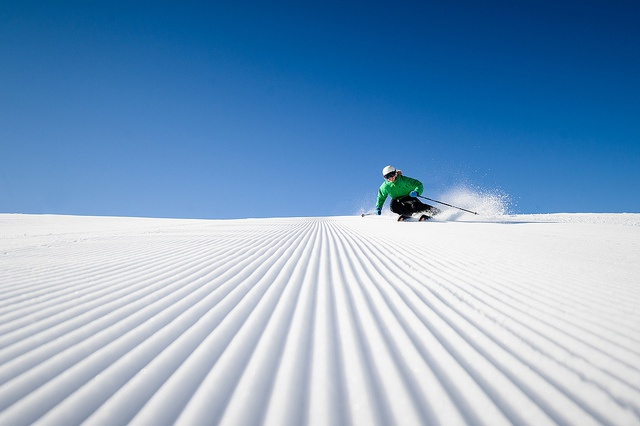Describe the objects in this image and their specific colors. I can see people in blue, black, darkgreen, darkgray, and lightgray tones and skis in blue, black, maroon, darkgray, and gray tones in this image. 